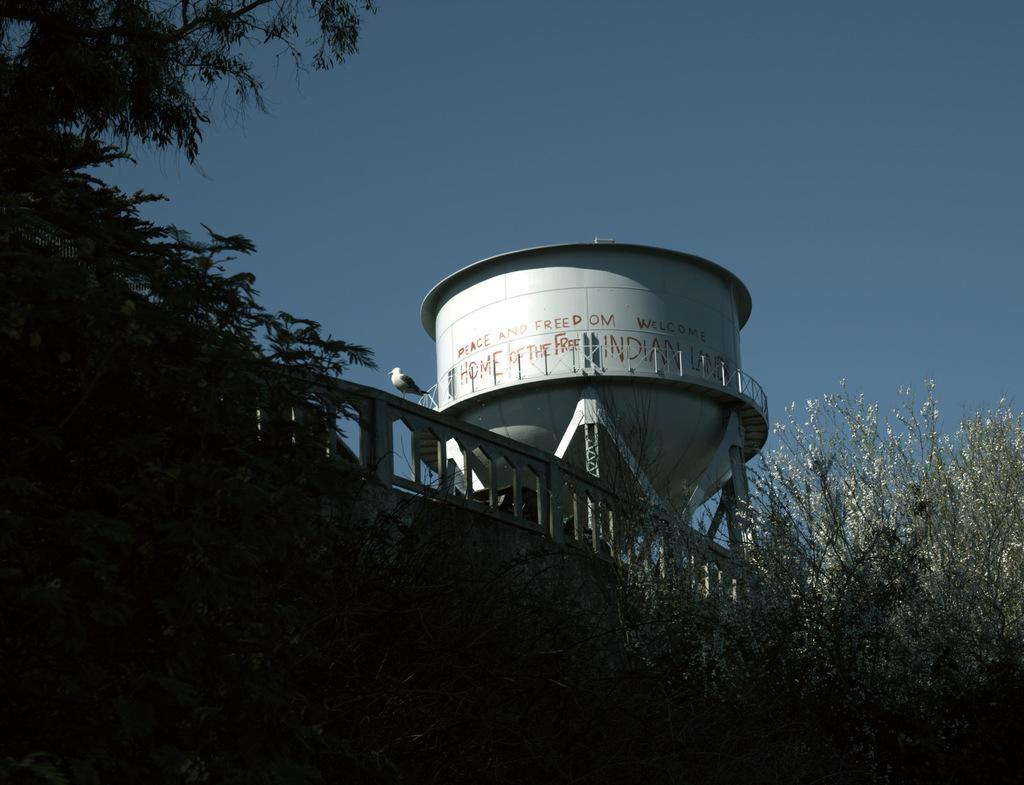What is the main object in the image? There is a water tank in the image. What else can be seen in the image besides the water tank? There is a bird on a fence and a group of trees in the image. What is visible in the background of the image? The sky is visible in the image. What is the name of the bird on the fence in the image? There is no way to determine the name of the bird from the image, as it is not mentioned or identifiable. 